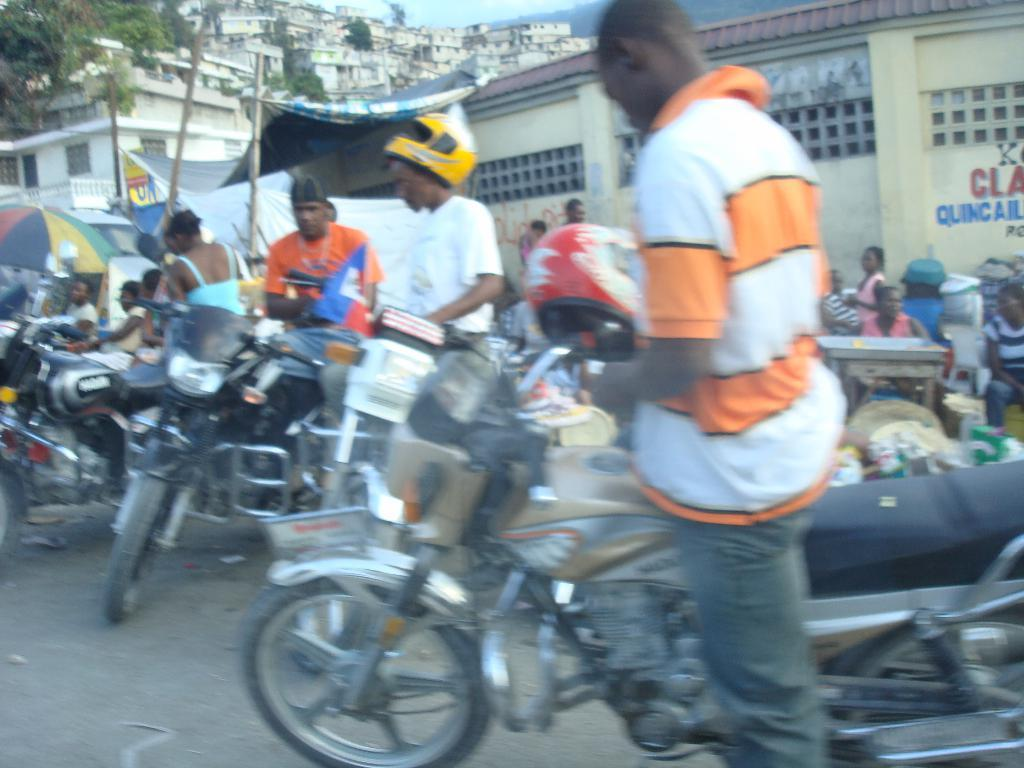What is visible at the top of the image? The sky is visible at the top of the image. What type of structures can be seen in the image? There are buildings in the image. What other natural elements are present in the image? There are trees in the image. What are the people in the image doing? There are persons sitting and standing on the road in the image. What mode of transportation is present in the image? Motorbikes are present in the image. What piece of furniture can be seen in the image? There is a table in the image. What type of toothbrush is being used by the person sitting on the table in the image? There is no person sitting on the table in the image, and no toothbrush is visible. 